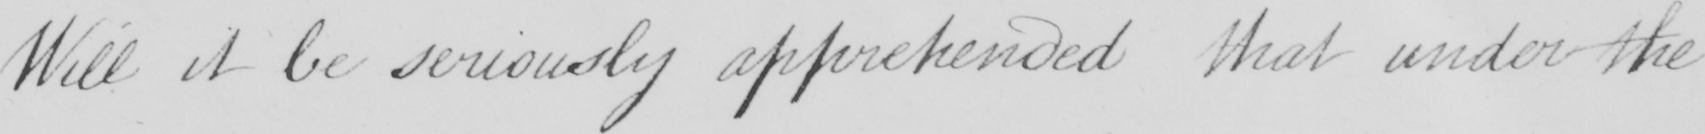Can you read and transcribe this handwriting? Will it be seriously apprehended that under the 